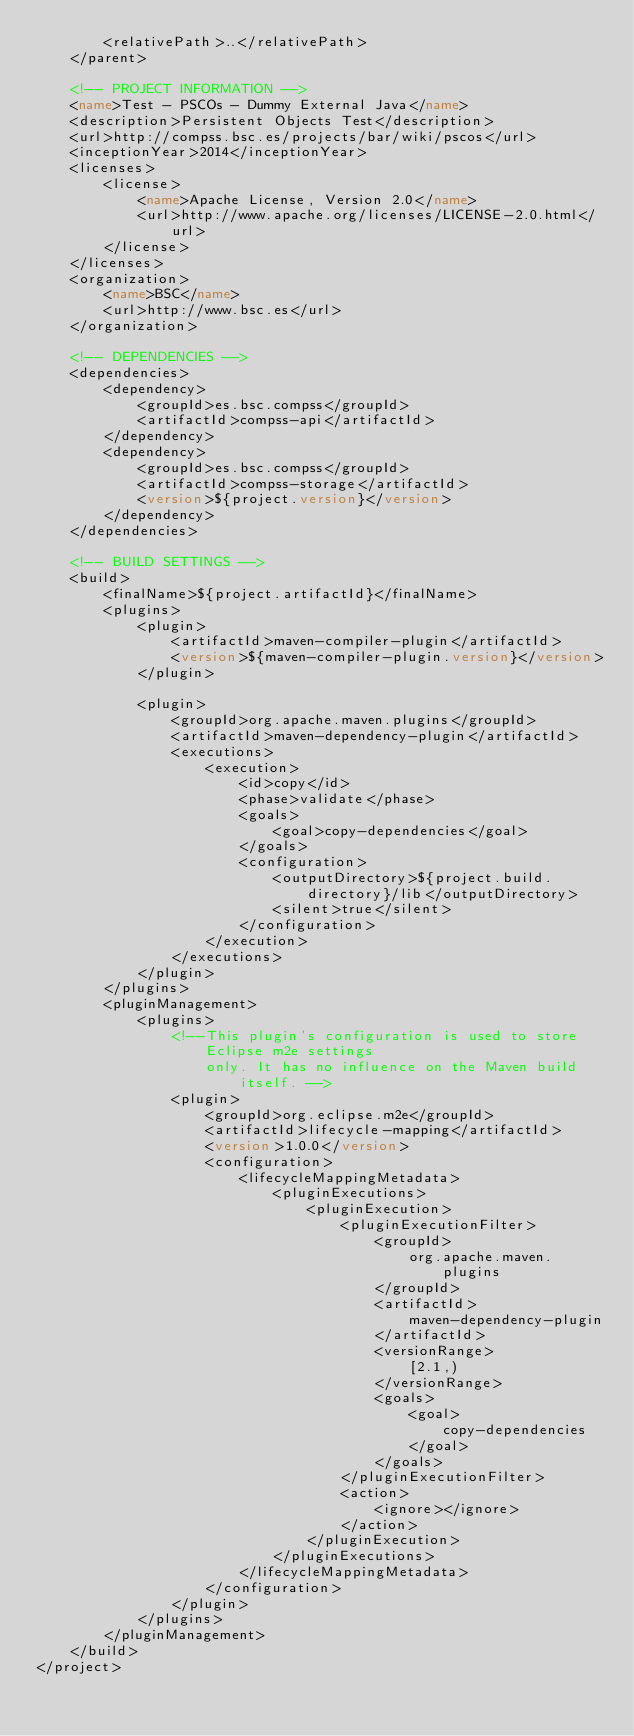Convert code to text. <code><loc_0><loc_0><loc_500><loc_500><_XML_>        <relativePath>..</relativePath>
    </parent>

    <!-- PROJECT INFORMATION -->
    <name>Test - PSCOs - Dummy External Java</name>
    <description>Persistent Objects Test</description>
    <url>http://compss.bsc.es/projects/bar/wiki/pscos</url>
    <inceptionYear>2014</inceptionYear>
    <licenses>
        <license>
            <name>Apache License, Version 2.0</name>
            <url>http://www.apache.org/licenses/LICENSE-2.0.html</url>
        </license>
    </licenses>
    <organization>
        <name>BSC</name>
        <url>http://www.bsc.es</url>
    </organization>

    <!-- DEPENDENCIES -->
    <dependencies>
        <dependency>
            <groupId>es.bsc.compss</groupId>
            <artifactId>compss-api</artifactId>
        </dependency>
        <dependency>
            <groupId>es.bsc.compss</groupId>
            <artifactId>compss-storage</artifactId>
            <version>${project.version}</version>
        </dependency>
    </dependencies>

    <!-- BUILD SETTINGS -->
    <build>
        <finalName>${project.artifactId}</finalName>
        <plugins>
            <plugin>
                <artifactId>maven-compiler-plugin</artifactId>
                <version>${maven-compiler-plugin.version}</version>
            </plugin>

            <plugin>
                <groupId>org.apache.maven.plugins</groupId>
                <artifactId>maven-dependency-plugin</artifactId>
                <executions>
                    <execution>
                        <id>copy</id>
                        <phase>validate</phase>
                        <goals>
                            <goal>copy-dependencies</goal>
                        </goals>
                        <configuration>
                            <outputDirectory>${project.build.directory}/lib</outputDirectory>
                            <silent>true</silent>
                        </configuration>
                    </execution>
                </executions>
            </plugin>
        </plugins>
        <pluginManagement>
            <plugins>
                <!--This plugin's configuration is used to store Eclipse m2e settings
                    only. It has no influence on the Maven build itself. -->
                <plugin>
                    <groupId>org.eclipse.m2e</groupId>
                    <artifactId>lifecycle-mapping</artifactId>
                    <version>1.0.0</version>
                    <configuration>
                        <lifecycleMappingMetadata>
                            <pluginExecutions>
                                <pluginExecution>
                                    <pluginExecutionFilter>
                                        <groupId>
                                            org.apache.maven.plugins
                                        </groupId>
                                        <artifactId>
                                            maven-dependency-plugin
                                        </artifactId>
                                        <versionRange>
                                            [2.1,)
                                        </versionRange>
                                        <goals>
                                            <goal>
                                                copy-dependencies
                                            </goal>
                                        </goals>
                                    </pluginExecutionFilter>
                                    <action>
                                        <ignore></ignore>
                                    </action>
                                </pluginExecution>
                            </pluginExecutions>
                        </lifecycleMappingMetadata>
                    </configuration>
                </plugin>
            </plugins>
        </pluginManagement>
    </build>
</project>
</code> 